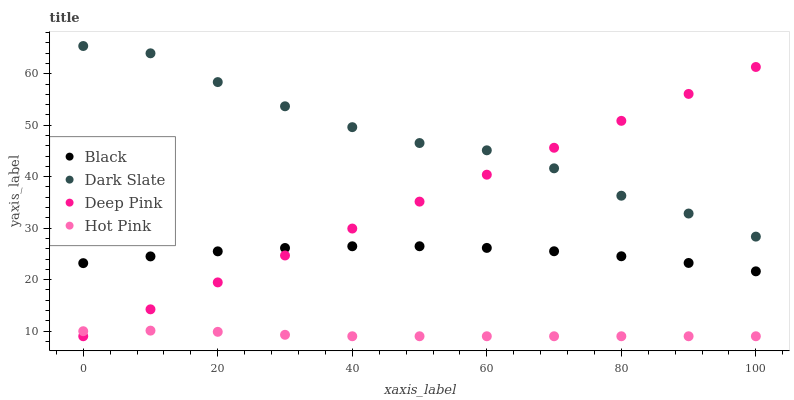Does Hot Pink have the minimum area under the curve?
Answer yes or no. Yes. Does Dark Slate have the maximum area under the curve?
Answer yes or no. Yes. Does Deep Pink have the minimum area under the curve?
Answer yes or no. No. Does Deep Pink have the maximum area under the curve?
Answer yes or no. No. Is Deep Pink the smoothest?
Answer yes or no. Yes. Is Dark Slate the roughest?
Answer yes or no. Yes. Is Black the smoothest?
Answer yes or no. No. Is Black the roughest?
Answer yes or no. No. Does Deep Pink have the lowest value?
Answer yes or no. Yes. Does Black have the lowest value?
Answer yes or no. No. Does Dark Slate have the highest value?
Answer yes or no. Yes. Does Deep Pink have the highest value?
Answer yes or no. No. Is Hot Pink less than Black?
Answer yes or no. Yes. Is Dark Slate greater than Black?
Answer yes or no. Yes. Does Dark Slate intersect Deep Pink?
Answer yes or no. Yes. Is Dark Slate less than Deep Pink?
Answer yes or no. No. Is Dark Slate greater than Deep Pink?
Answer yes or no. No. Does Hot Pink intersect Black?
Answer yes or no. No. 